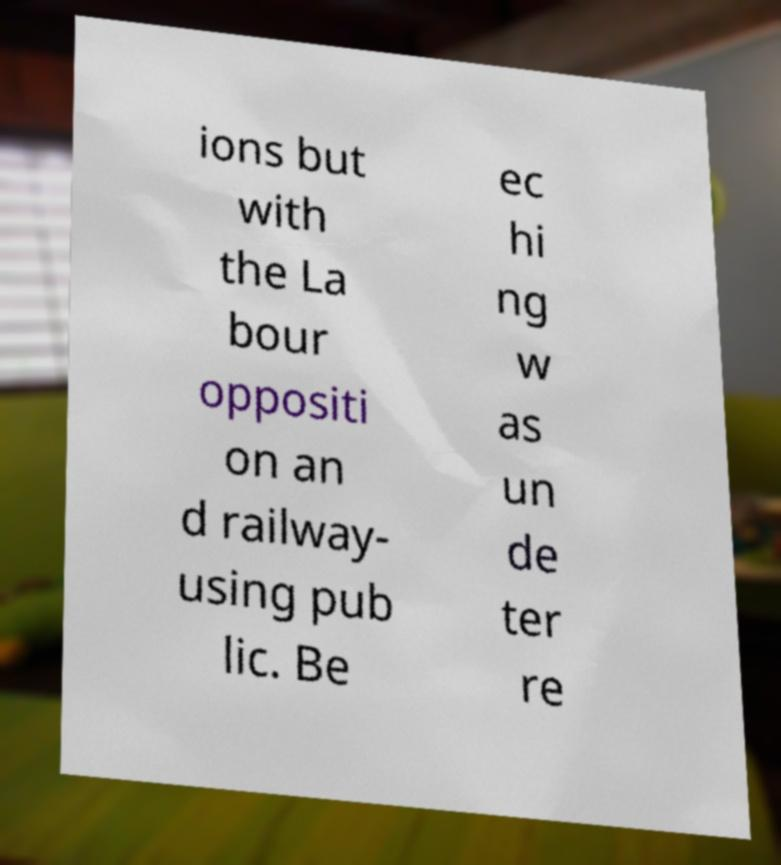Could you extract and type out the text from this image? ions but with the La bour oppositi on an d railway- using pub lic. Be ec hi ng w as un de ter re 